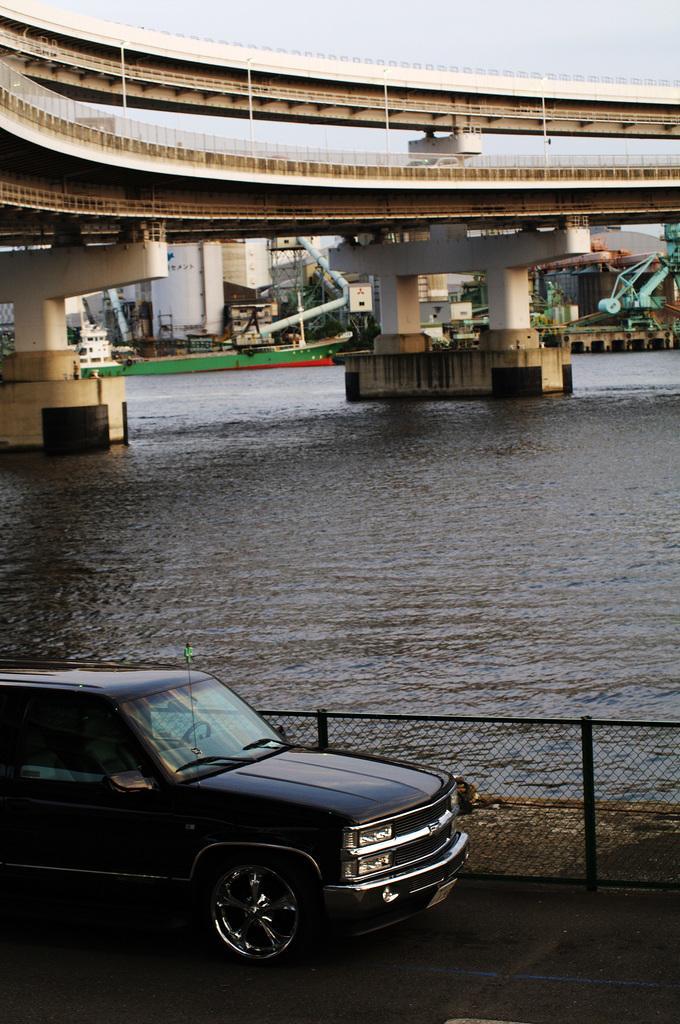Describe this image in one or two sentences. In this image, we can see a vehicle. We can see the fence and some water. We can also see the bridge and some houses. We can also see some objects in the background. We can also see the sky. 